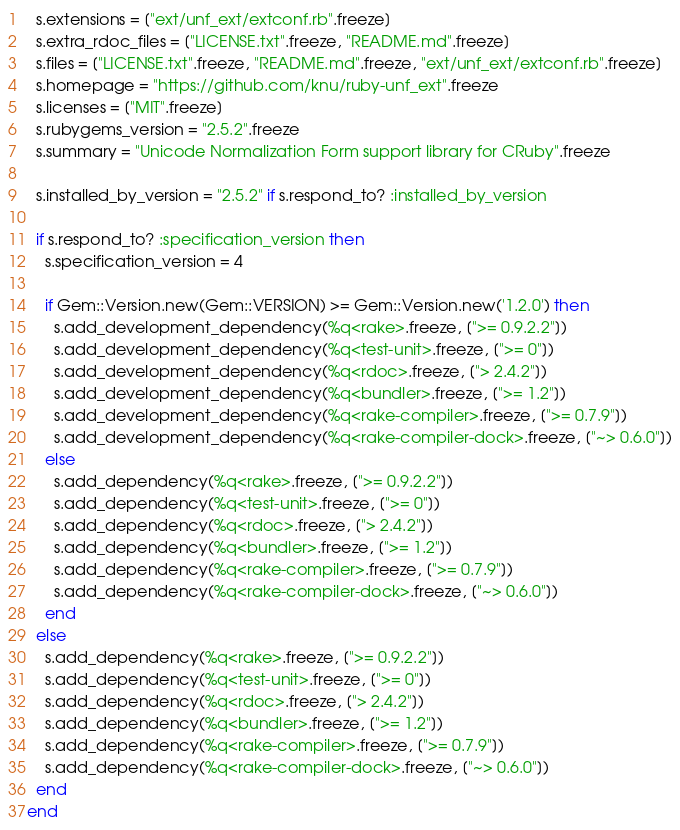<code> <loc_0><loc_0><loc_500><loc_500><_Ruby_>  s.extensions = ["ext/unf_ext/extconf.rb".freeze]
  s.extra_rdoc_files = ["LICENSE.txt".freeze, "README.md".freeze]
  s.files = ["LICENSE.txt".freeze, "README.md".freeze, "ext/unf_ext/extconf.rb".freeze]
  s.homepage = "https://github.com/knu/ruby-unf_ext".freeze
  s.licenses = ["MIT".freeze]
  s.rubygems_version = "2.5.2".freeze
  s.summary = "Unicode Normalization Form support library for CRuby".freeze

  s.installed_by_version = "2.5.2" if s.respond_to? :installed_by_version

  if s.respond_to? :specification_version then
    s.specification_version = 4

    if Gem::Version.new(Gem::VERSION) >= Gem::Version.new('1.2.0') then
      s.add_development_dependency(%q<rake>.freeze, [">= 0.9.2.2"])
      s.add_development_dependency(%q<test-unit>.freeze, [">= 0"])
      s.add_development_dependency(%q<rdoc>.freeze, ["> 2.4.2"])
      s.add_development_dependency(%q<bundler>.freeze, [">= 1.2"])
      s.add_development_dependency(%q<rake-compiler>.freeze, [">= 0.7.9"])
      s.add_development_dependency(%q<rake-compiler-dock>.freeze, ["~> 0.6.0"])
    else
      s.add_dependency(%q<rake>.freeze, [">= 0.9.2.2"])
      s.add_dependency(%q<test-unit>.freeze, [">= 0"])
      s.add_dependency(%q<rdoc>.freeze, ["> 2.4.2"])
      s.add_dependency(%q<bundler>.freeze, [">= 1.2"])
      s.add_dependency(%q<rake-compiler>.freeze, [">= 0.7.9"])
      s.add_dependency(%q<rake-compiler-dock>.freeze, ["~> 0.6.0"])
    end
  else
    s.add_dependency(%q<rake>.freeze, [">= 0.9.2.2"])
    s.add_dependency(%q<test-unit>.freeze, [">= 0"])
    s.add_dependency(%q<rdoc>.freeze, ["> 2.4.2"])
    s.add_dependency(%q<bundler>.freeze, [">= 1.2"])
    s.add_dependency(%q<rake-compiler>.freeze, [">= 0.7.9"])
    s.add_dependency(%q<rake-compiler-dock>.freeze, ["~> 0.6.0"])
  end
end
</code> 